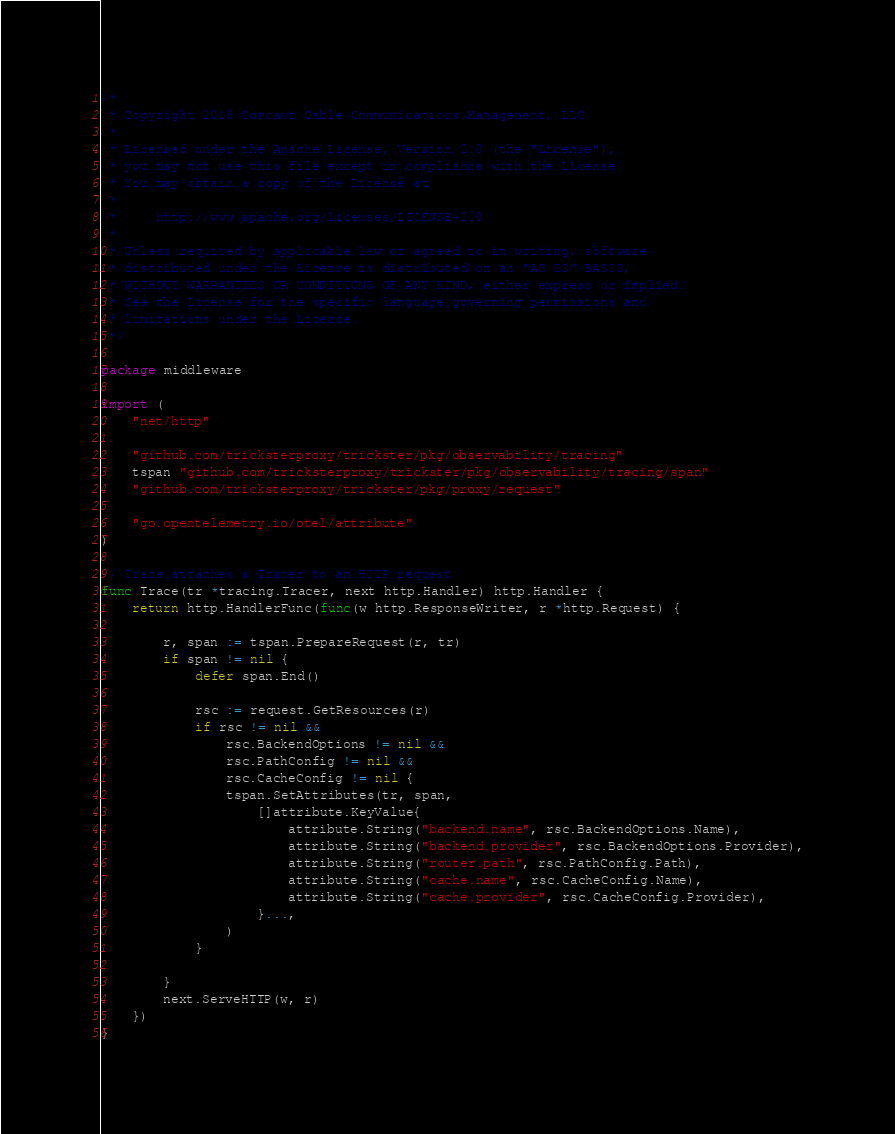Convert code to text. <code><loc_0><loc_0><loc_500><loc_500><_Go_>/*
 * Copyright 2018 Comcast Cable Communications Management, LLC
 *
 * Licensed under the Apache License, Version 2.0 (the "License");
 * you may not use this file except in compliance with the License.
 * You may obtain a copy of the License at
 *
 *     http://www.apache.org/licenses/LICENSE-2.0
 *
 * Unless required by applicable law or agreed to in writing, software
 * distributed under the License is distributed on an "AS IS" BASIS,
 * WITHOUT WARRANTIES OR CONDITIONS OF ANY KIND, either express or implied.
 * See the License for the specific language governing permissions and
 * limitations under the License.
 */

package middleware

import (
	"net/http"

	"github.com/tricksterproxy/trickster/pkg/observability/tracing"
	tspan "github.com/tricksterproxy/trickster/pkg/observability/tracing/span"
	"github.com/tricksterproxy/trickster/pkg/proxy/request"

	"go.opentelemetry.io/otel/attribute"
)

// Trace attaches a Tracer to an HTTP request
func Trace(tr *tracing.Tracer, next http.Handler) http.Handler {
	return http.HandlerFunc(func(w http.ResponseWriter, r *http.Request) {

		r, span := tspan.PrepareRequest(r, tr)
		if span != nil {
			defer span.End()

			rsc := request.GetResources(r)
			if rsc != nil &&
				rsc.BackendOptions != nil &&
				rsc.PathConfig != nil &&
				rsc.CacheConfig != nil {
				tspan.SetAttributes(tr, span,
					[]attribute.KeyValue{
						attribute.String("backend.name", rsc.BackendOptions.Name),
						attribute.String("backend.provider", rsc.BackendOptions.Provider),
						attribute.String("router.path", rsc.PathConfig.Path),
						attribute.String("cache.name", rsc.CacheConfig.Name),
						attribute.String("cache.provider", rsc.CacheConfig.Provider),
					}...,
				)
			}

		}
		next.ServeHTTP(w, r)
	})
}
</code> 